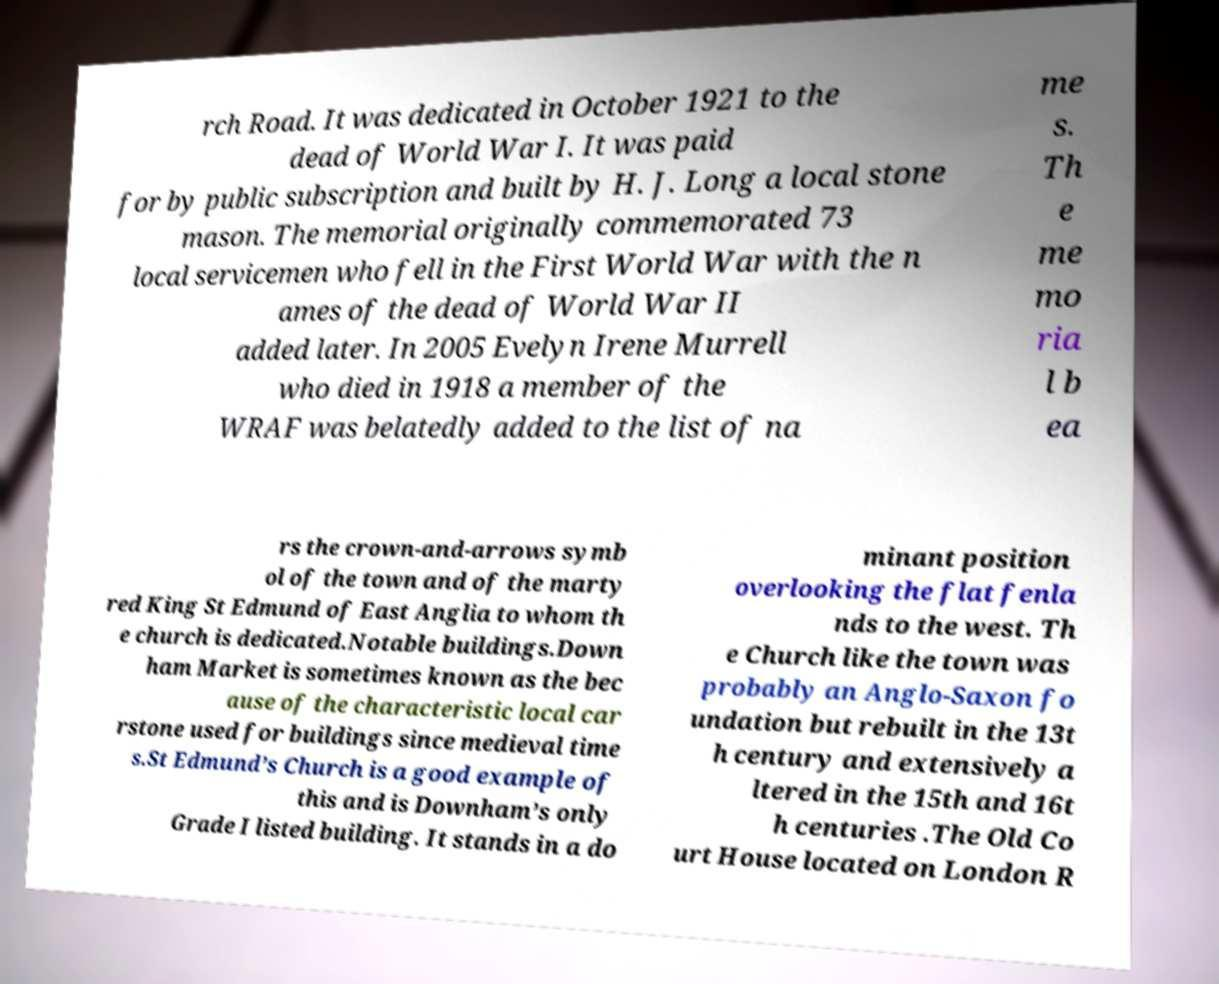Can you read and provide the text displayed in the image?This photo seems to have some interesting text. Can you extract and type it out for me? rch Road. It was dedicated in October 1921 to the dead of World War I. It was paid for by public subscription and built by H. J. Long a local stone mason. The memorial originally commemorated 73 local servicemen who fell in the First World War with the n ames of the dead of World War II added later. In 2005 Evelyn Irene Murrell who died in 1918 a member of the WRAF was belatedly added to the list of na me s. Th e me mo ria l b ea rs the crown-and-arrows symb ol of the town and of the marty red King St Edmund of East Anglia to whom th e church is dedicated.Notable buildings.Down ham Market is sometimes known as the bec ause of the characteristic local car rstone used for buildings since medieval time s.St Edmund’s Church is a good example of this and is Downham’s only Grade I listed building. It stands in a do minant position overlooking the flat fenla nds to the west. Th e Church like the town was probably an Anglo-Saxon fo undation but rebuilt in the 13t h century and extensively a ltered in the 15th and 16t h centuries .The Old Co urt House located on London R 